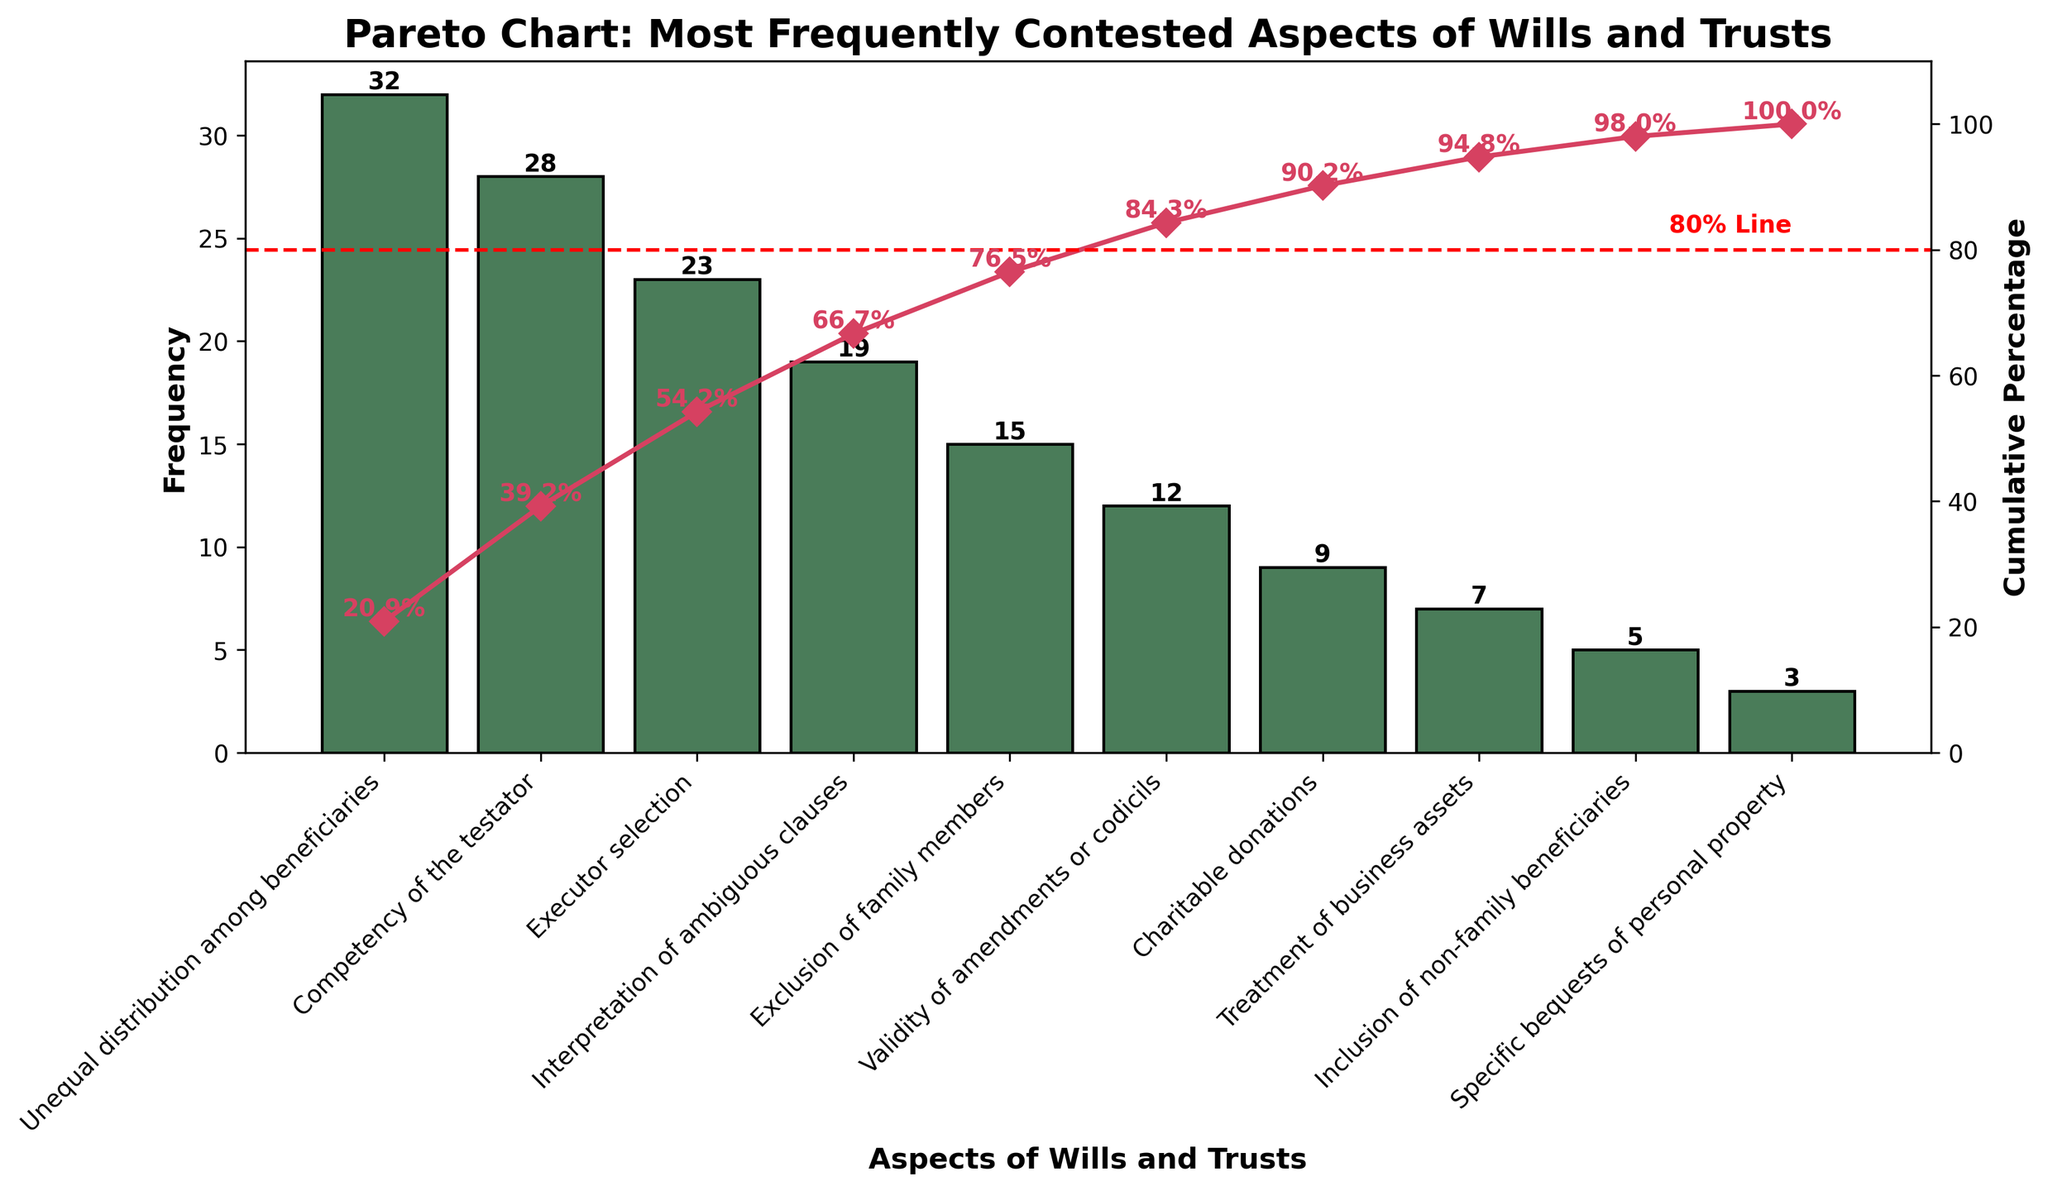Which aspect is most frequently contested in wills and trusts? The tallest bar in the chart represents the most frequently contested aspect. "Unequal distribution among beneficiaries" has the highest frequency at 32.
Answer: Unequal distribution among beneficiaries What is the cumulative percentage for the top two most contested aspects? The cumulative percentage line shows this value on the secondary y-axis. For "Unequal distribution among beneficiaries" (32) and "Competency of the testator" (28), the respective values are added: 32 + 28 = 60. Referring to the cumulative percentage line at the second bar, it is around 59.3%.
Answer: 59.3% How many aspects account for approximately 80% of the cumulative reported issues? The 80% threshold line helps in identifying this. Visual inspection shows the bars for "Unequal distribution among beneficiaries", "Competency of the testator", "Executor selection", and "Interpretation of ambiguous clauses" reach up to around 85.1% cumulative percentage. So up to the fourth aspect is needed.
Answer: 4 Is "Treatment of business assets" more or less frequently contested than "Exclusion of family members"? Comparing the height of the bars for these aspects, "Treatment of business assets" has a frequency of 7 while "Exclusion of family members" has a frequency of 15. Therefore, "Treatment of business assets" is less frequently contested.
Answer: Less What is the combined frequency for exclusion of family members and charitable donations? The bar heights for "Exclusion of family members" and "Charitable donations" are 15 and 9, respectively. Adding these values results in 15 + 9 = 24.
Answer: 24 Which aspect ranks fifth in terms of frequency? Counting down the bars from the most frequent to the fifth bar, "Exclusion of family members" is the fifth aspect with a frequency of 15.
Answer: Exclusion of family members What percentage of the cumulative frequency is achieved by the sum of the first three aspects? The cumulative percentages shown on the secondary y-axis for the first three aspects, "Unequal distribution among beneficiaries", "Competency of the testator", and "Executor selection", when looked at together, reach around 78%.
Answer: 78% Which aspect has the lowest frequency, and what is its exact frequency value? The shortest bar represents the least frequently contested aspect, which is "Specific bequests of personal property" with a frequency of 3.
Answer: Specific bequests of personal property, 3 What is the difference in frequency between the aspect with the highest and lowest frequency? Subtracting the lowest frequency (3) from the highest frequency (32) gives 32 - 3 = 29.
Answer: 29 What is the average frequency of all aspects listed in the chart? Adding all the frequencies and dividing by the number of aspects gives: (32 + 28 + 23 + 19 + 15 + 12 + 9 + 7 + 5 + 3) = 153, and 153 / 10 = 15.3.
Answer: 15.3 